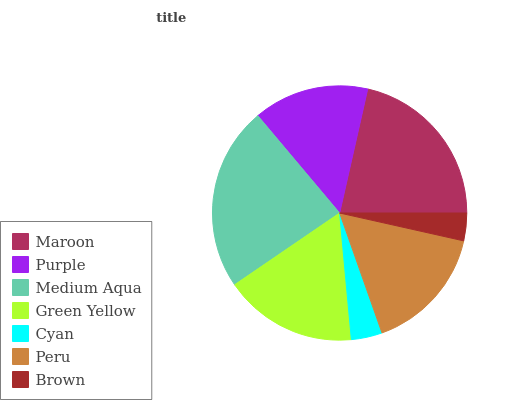Is Brown the minimum?
Answer yes or no. Yes. Is Medium Aqua the maximum?
Answer yes or no. Yes. Is Purple the minimum?
Answer yes or no. No. Is Purple the maximum?
Answer yes or no. No. Is Maroon greater than Purple?
Answer yes or no. Yes. Is Purple less than Maroon?
Answer yes or no. Yes. Is Purple greater than Maroon?
Answer yes or no. No. Is Maroon less than Purple?
Answer yes or no. No. Is Peru the high median?
Answer yes or no. Yes. Is Peru the low median?
Answer yes or no. Yes. Is Brown the high median?
Answer yes or no. No. Is Medium Aqua the low median?
Answer yes or no. No. 